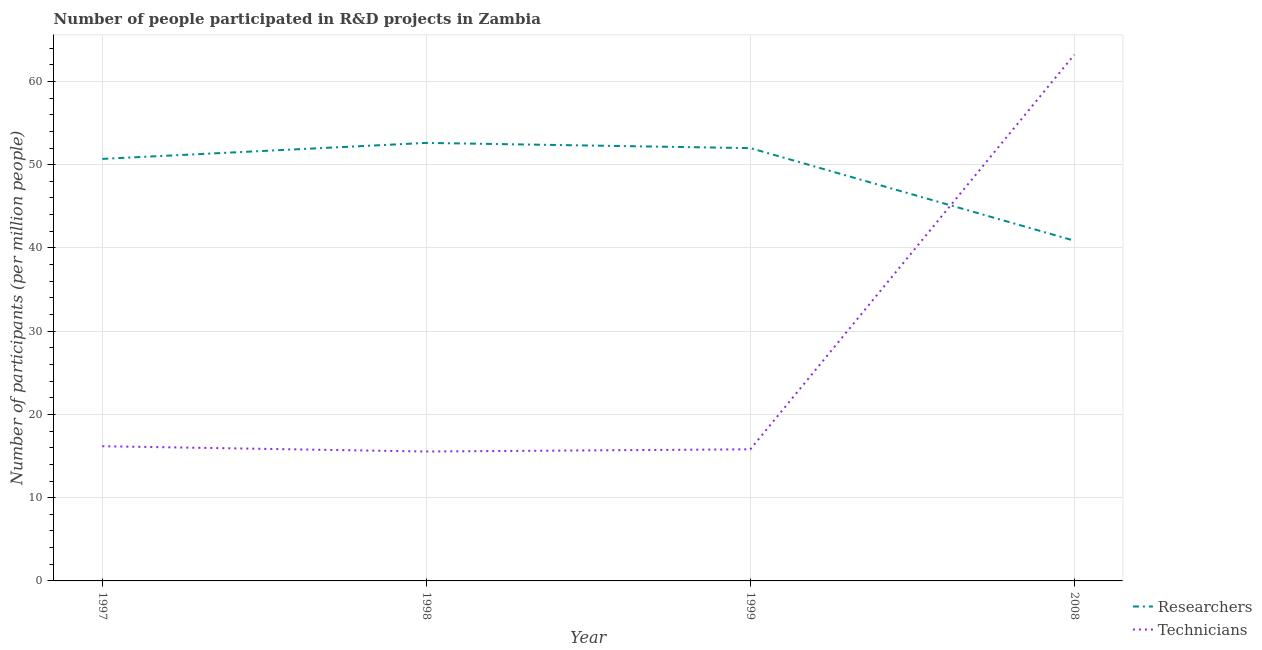How many different coloured lines are there?
Make the answer very short. 2. What is the number of technicians in 1999?
Ensure brevity in your answer.  15.81. Across all years, what is the maximum number of technicians?
Offer a terse response. 63.21. Across all years, what is the minimum number of researchers?
Offer a very short reply. 40.87. In which year was the number of researchers maximum?
Keep it short and to the point. 1998. In which year was the number of technicians minimum?
Provide a short and direct response. 1998. What is the total number of technicians in the graph?
Give a very brief answer. 110.75. What is the difference between the number of technicians in 1999 and that in 2008?
Provide a short and direct response. -47.4. What is the difference between the number of technicians in 1999 and the number of researchers in 1997?
Your response must be concise. -34.89. What is the average number of researchers per year?
Your answer should be very brief. 49.04. In the year 1997, what is the difference between the number of researchers and number of technicians?
Your answer should be compact. 34.52. In how many years, is the number of researchers greater than 38?
Your answer should be compact. 4. What is the ratio of the number of technicians in 1997 to that in 1999?
Your answer should be compact. 1.02. What is the difference between the highest and the second highest number of researchers?
Your answer should be compact. 0.63. What is the difference between the highest and the lowest number of researchers?
Make the answer very short. 11.75. Is the sum of the number of technicians in 1998 and 1999 greater than the maximum number of researchers across all years?
Your response must be concise. No. Does the number of technicians monotonically increase over the years?
Offer a terse response. No. Is the number of technicians strictly greater than the number of researchers over the years?
Your response must be concise. No. Is the number of technicians strictly less than the number of researchers over the years?
Your answer should be compact. No. How many years are there in the graph?
Your answer should be very brief. 4. What is the difference between two consecutive major ticks on the Y-axis?
Your answer should be compact. 10. Does the graph contain any zero values?
Give a very brief answer. No. Does the graph contain grids?
Ensure brevity in your answer.  Yes. Where does the legend appear in the graph?
Make the answer very short. Bottom right. How many legend labels are there?
Offer a very short reply. 2. What is the title of the graph?
Keep it short and to the point. Number of people participated in R&D projects in Zambia. Does "Urban" appear as one of the legend labels in the graph?
Provide a short and direct response. No. What is the label or title of the Y-axis?
Your answer should be very brief. Number of participants (per million people). What is the Number of participants (per million people) in Researchers in 1997?
Offer a very short reply. 50.7. What is the Number of participants (per million people) in Technicians in 1997?
Keep it short and to the point. 16.18. What is the Number of participants (per million people) in Researchers in 1998?
Offer a very short reply. 52.62. What is the Number of participants (per million people) of Technicians in 1998?
Keep it short and to the point. 15.55. What is the Number of participants (per million people) of Researchers in 1999?
Offer a very short reply. 51.99. What is the Number of participants (per million people) in Technicians in 1999?
Your response must be concise. 15.81. What is the Number of participants (per million people) in Researchers in 2008?
Your answer should be very brief. 40.87. What is the Number of participants (per million people) of Technicians in 2008?
Your response must be concise. 63.21. Across all years, what is the maximum Number of participants (per million people) of Researchers?
Offer a very short reply. 52.62. Across all years, what is the maximum Number of participants (per million people) of Technicians?
Your response must be concise. 63.21. Across all years, what is the minimum Number of participants (per million people) of Researchers?
Provide a short and direct response. 40.87. Across all years, what is the minimum Number of participants (per million people) of Technicians?
Offer a terse response. 15.55. What is the total Number of participants (per million people) in Researchers in the graph?
Your answer should be compact. 196.18. What is the total Number of participants (per million people) in Technicians in the graph?
Your response must be concise. 110.75. What is the difference between the Number of participants (per million people) of Researchers in 1997 and that in 1998?
Provide a short and direct response. -1.92. What is the difference between the Number of participants (per million people) in Technicians in 1997 and that in 1998?
Your response must be concise. 0.64. What is the difference between the Number of participants (per million people) of Researchers in 1997 and that in 1999?
Provide a short and direct response. -1.29. What is the difference between the Number of participants (per million people) in Technicians in 1997 and that in 1999?
Provide a succinct answer. 0.37. What is the difference between the Number of participants (per million people) of Researchers in 1997 and that in 2008?
Your answer should be compact. 9.83. What is the difference between the Number of participants (per million people) of Technicians in 1997 and that in 2008?
Provide a succinct answer. -47.03. What is the difference between the Number of participants (per million people) in Researchers in 1998 and that in 1999?
Give a very brief answer. 0.63. What is the difference between the Number of participants (per million people) in Technicians in 1998 and that in 1999?
Keep it short and to the point. -0.26. What is the difference between the Number of participants (per million people) in Researchers in 1998 and that in 2008?
Provide a short and direct response. 11.75. What is the difference between the Number of participants (per million people) in Technicians in 1998 and that in 2008?
Provide a succinct answer. -47.67. What is the difference between the Number of participants (per million people) in Researchers in 1999 and that in 2008?
Keep it short and to the point. 11.12. What is the difference between the Number of participants (per million people) of Technicians in 1999 and that in 2008?
Your answer should be compact. -47.4. What is the difference between the Number of participants (per million people) of Researchers in 1997 and the Number of participants (per million people) of Technicians in 1998?
Provide a succinct answer. 35.15. What is the difference between the Number of participants (per million people) in Researchers in 1997 and the Number of participants (per million people) in Technicians in 1999?
Your response must be concise. 34.89. What is the difference between the Number of participants (per million people) in Researchers in 1997 and the Number of participants (per million people) in Technicians in 2008?
Keep it short and to the point. -12.51. What is the difference between the Number of participants (per million people) in Researchers in 1998 and the Number of participants (per million people) in Technicians in 1999?
Ensure brevity in your answer.  36.81. What is the difference between the Number of participants (per million people) of Researchers in 1998 and the Number of participants (per million people) of Technicians in 2008?
Offer a very short reply. -10.59. What is the difference between the Number of participants (per million people) in Researchers in 1999 and the Number of participants (per million people) in Technicians in 2008?
Give a very brief answer. -11.22. What is the average Number of participants (per million people) of Researchers per year?
Provide a short and direct response. 49.04. What is the average Number of participants (per million people) of Technicians per year?
Offer a very short reply. 27.69. In the year 1997, what is the difference between the Number of participants (per million people) in Researchers and Number of participants (per million people) in Technicians?
Make the answer very short. 34.52. In the year 1998, what is the difference between the Number of participants (per million people) of Researchers and Number of participants (per million people) of Technicians?
Offer a very short reply. 37.07. In the year 1999, what is the difference between the Number of participants (per million people) in Researchers and Number of participants (per million people) in Technicians?
Your answer should be very brief. 36.18. In the year 2008, what is the difference between the Number of participants (per million people) of Researchers and Number of participants (per million people) of Technicians?
Ensure brevity in your answer.  -22.34. What is the ratio of the Number of participants (per million people) of Researchers in 1997 to that in 1998?
Provide a succinct answer. 0.96. What is the ratio of the Number of participants (per million people) of Technicians in 1997 to that in 1998?
Ensure brevity in your answer.  1.04. What is the ratio of the Number of participants (per million people) of Researchers in 1997 to that in 1999?
Your answer should be very brief. 0.98. What is the ratio of the Number of participants (per million people) of Technicians in 1997 to that in 1999?
Your response must be concise. 1.02. What is the ratio of the Number of participants (per million people) of Researchers in 1997 to that in 2008?
Offer a terse response. 1.24. What is the ratio of the Number of participants (per million people) in Technicians in 1997 to that in 2008?
Offer a terse response. 0.26. What is the ratio of the Number of participants (per million people) of Researchers in 1998 to that in 1999?
Provide a succinct answer. 1.01. What is the ratio of the Number of participants (per million people) of Technicians in 1998 to that in 1999?
Offer a very short reply. 0.98. What is the ratio of the Number of participants (per million people) of Researchers in 1998 to that in 2008?
Provide a succinct answer. 1.29. What is the ratio of the Number of participants (per million people) in Technicians in 1998 to that in 2008?
Provide a short and direct response. 0.25. What is the ratio of the Number of participants (per million people) of Researchers in 1999 to that in 2008?
Your response must be concise. 1.27. What is the ratio of the Number of participants (per million people) in Technicians in 1999 to that in 2008?
Offer a terse response. 0.25. What is the difference between the highest and the second highest Number of participants (per million people) in Researchers?
Your answer should be compact. 0.63. What is the difference between the highest and the second highest Number of participants (per million people) in Technicians?
Make the answer very short. 47.03. What is the difference between the highest and the lowest Number of participants (per million people) of Researchers?
Give a very brief answer. 11.75. What is the difference between the highest and the lowest Number of participants (per million people) in Technicians?
Ensure brevity in your answer.  47.67. 